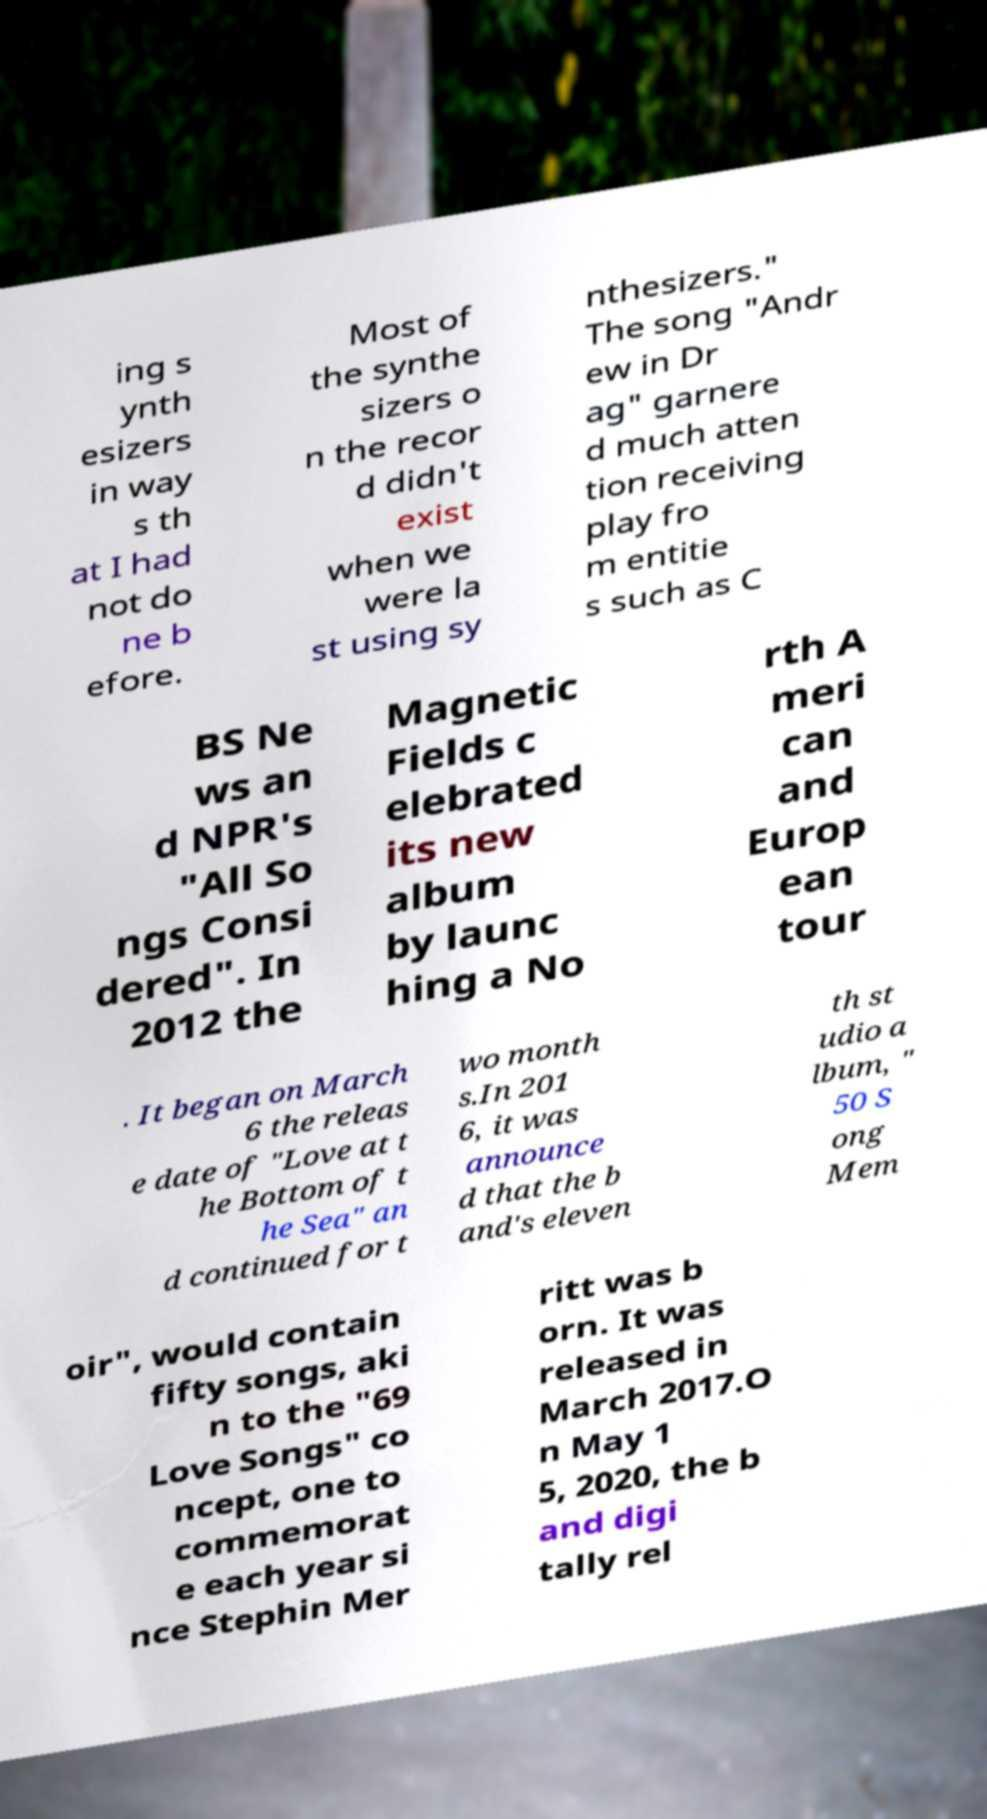There's text embedded in this image that I need extracted. Can you transcribe it verbatim? ing s ynth esizers in way s th at I had not do ne b efore. Most of the synthe sizers o n the recor d didn't exist when we were la st using sy nthesizers." The song "Andr ew in Dr ag" garnere d much atten tion receiving play fro m entitie s such as C BS Ne ws an d NPR's "All So ngs Consi dered". In 2012 the Magnetic Fields c elebrated its new album by launc hing a No rth A meri can and Europ ean tour . It began on March 6 the releas e date of "Love at t he Bottom of t he Sea" an d continued for t wo month s.In 201 6, it was announce d that the b and's eleven th st udio a lbum, " 50 S ong Mem oir", would contain fifty songs, aki n to the "69 Love Songs" co ncept, one to commemorat e each year si nce Stephin Mer ritt was b orn. It was released in March 2017.O n May 1 5, 2020, the b and digi tally rel 